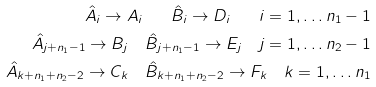<formula> <loc_0><loc_0><loc_500><loc_500>\hat { A } _ { i } \rightarrow A _ { i } \quad \hat { B } _ { i } \rightarrow D _ { i } \quad i = 1 , \dots n _ { 1 } - 1 \\ \hat { A } _ { j + n _ { 1 } - 1 } \rightarrow B _ { j } \quad \hat { B } _ { j + n _ { 1 } - 1 } \rightarrow E _ { j } \quad j = 1 , \dots n _ { 2 } - 1 \\ \hat { A } _ { k + n _ { 1 } + n _ { 2 } - 2 } \rightarrow C _ { k } \quad \hat { B } _ { k + n _ { 1 } + n _ { 2 } - 2 } \rightarrow F _ { k } \quad k = 1 , \dots n _ { 1 }</formula> 